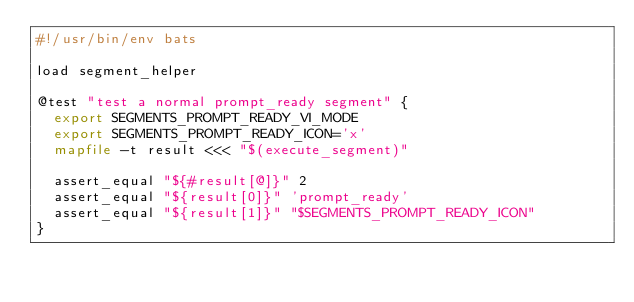<code> <loc_0><loc_0><loc_500><loc_500><_Bash_>#!/usr/bin/env bats

load segment_helper

@test "test a normal prompt_ready segment" {
  export SEGMENTS_PROMPT_READY_VI_MODE
  export SEGMENTS_PROMPT_READY_ICON='x'
  mapfile -t result <<< "$(execute_segment)"

  assert_equal "${#result[@]}" 2
  assert_equal "${result[0]}" 'prompt_ready'
  assert_equal "${result[1]}" "$SEGMENTS_PROMPT_READY_ICON"
}

</code> 